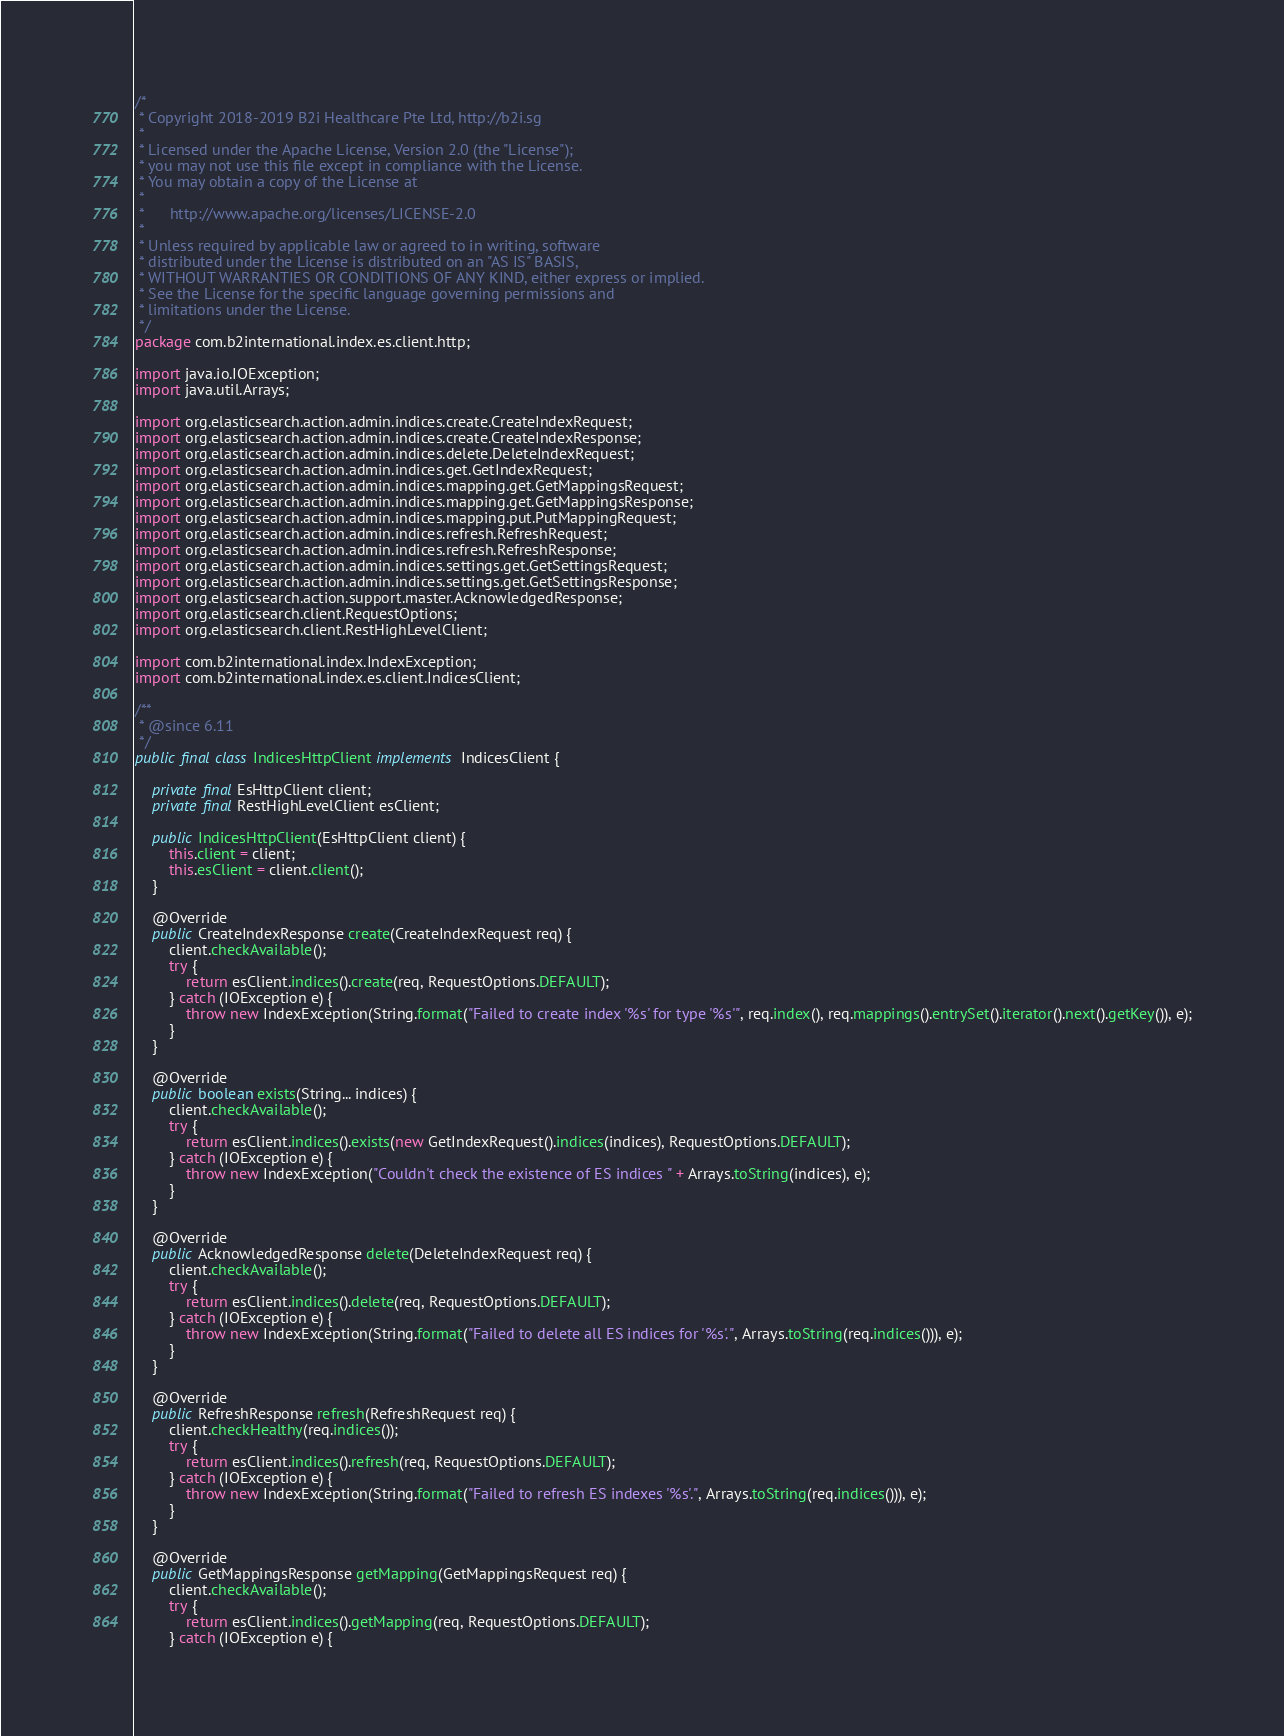Convert code to text. <code><loc_0><loc_0><loc_500><loc_500><_Java_>/*
 * Copyright 2018-2019 B2i Healthcare Pte Ltd, http://b2i.sg
 * 
 * Licensed under the Apache License, Version 2.0 (the "License");
 * you may not use this file except in compliance with the License.
 * You may obtain a copy of the License at
 *
 *      http://www.apache.org/licenses/LICENSE-2.0
 *
 * Unless required by applicable law or agreed to in writing, software
 * distributed under the License is distributed on an "AS IS" BASIS,
 * WITHOUT WARRANTIES OR CONDITIONS OF ANY KIND, either express or implied.
 * See the License for the specific language governing permissions and
 * limitations under the License.
 */
package com.b2international.index.es.client.http;

import java.io.IOException;
import java.util.Arrays;

import org.elasticsearch.action.admin.indices.create.CreateIndexRequest;
import org.elasticsearch.action.admin.indices.create.CreateIndexResponse;
import org.elasticsearch.action.admin.indices.delete.DeleteIndexRequest;
import org.elasticsearch.action.admin.indices.get.GetIndexRequest;
import org.elasticsearch.action.admin.indices.mapping.get.GetMappingsRequest;
import org.elasticsearch.action.admin.indices.mapping.get.GetMappingsResponse;
import org.elasticsearch.action.admin.indices.mapping.put.PutMappingRequest;
import org.elasticsearch.action.admin.indices.refresh.RefreshRequest;
import org.elasticsearch.action.admin.indices.refresh.RefreshResponse;
import org.elasticsearch.action.admin.indices.settings.get.GetSettingsRequest;
import org.elasticsearch.action.admin.indices.settings.get.GetSettingsResponse;
import org.elasticsearch.action.support.master.AcknowledgedResponse;
import org.elasticsearch.client.RequestOptions;
import org.elasticsearch.client.RestHighLevelClient;

import com.b2international.index.IndexException;
import com.b2international.index.es.client.IndicesClient;

/**
 * @since 6.11
 */
public final class IndicesHttpClient implements IndicesClient {

	private final EsHttpClient client;
	private final RestHighLevelClient esClient;

	public IndicesHttpClient(EsHttpClient client) {
		this.client = client;
		this.esClient = client.client();
	}
	
	@Override
	public CreateIndexResponse create(CreateIndexRequest req) {
		client.checkAvailable();
		try {
			return esClient.indices().create(req, RequestOptions.DEFAULT);
		} catch (IOException e) {
			throw new IndexException(String.format("Failed to create index '%s' for type '%s'", req.index(), req.mappings().entrySet().iterator().next().getKey()), e);
		}
	}
	
	@Override
	public boolean exists(String... indices) {
		client.checkAvailable();
		try {
			return esClient.indices().exists(new GetIndexRequest().indices(indices), RequestOptions.DEFAULT);
		} catch (IOException e) {
			throw new IndexException("Couldn't check the existence of ES indices " + Arrays.toString(indices), e);
		}
	}

	@Override
	public AcknowledgedResponse delete(DeleteIndexRequest req) {
		client.checkAvailable();
		try {
			return esClient.indices().delete(req, RequestOptions.DEFAULT);
		} catch (IOException e) {
			throw new IndexException(String.format("Failed to delete all ES indices for '%s'.", Arrays.toString(req.indices())), e);
		}
	}

	@Override
	public RefreshResponse refresh(RefreshRequest req) {
		client.checkHealthy(req.indices());
		try {
			return esClient.indices().refresh(req, RequestOptions.DEFAULT);
		} catch (IOException e) {
			throw new IndexException(String.format("Failed to refresh ES indexes '%s'.", Arrays.toString(req.indices())), e);
		}
	}
	
	@Override
	public GetMappingsResponse getMapping(GetMappingsRequest req) {
		client.checkAvailable();
		try {
			return esClient.indices().getMapping(req, RequestOptions.DEFAULT);
		} catch (IOException e) {</code> 